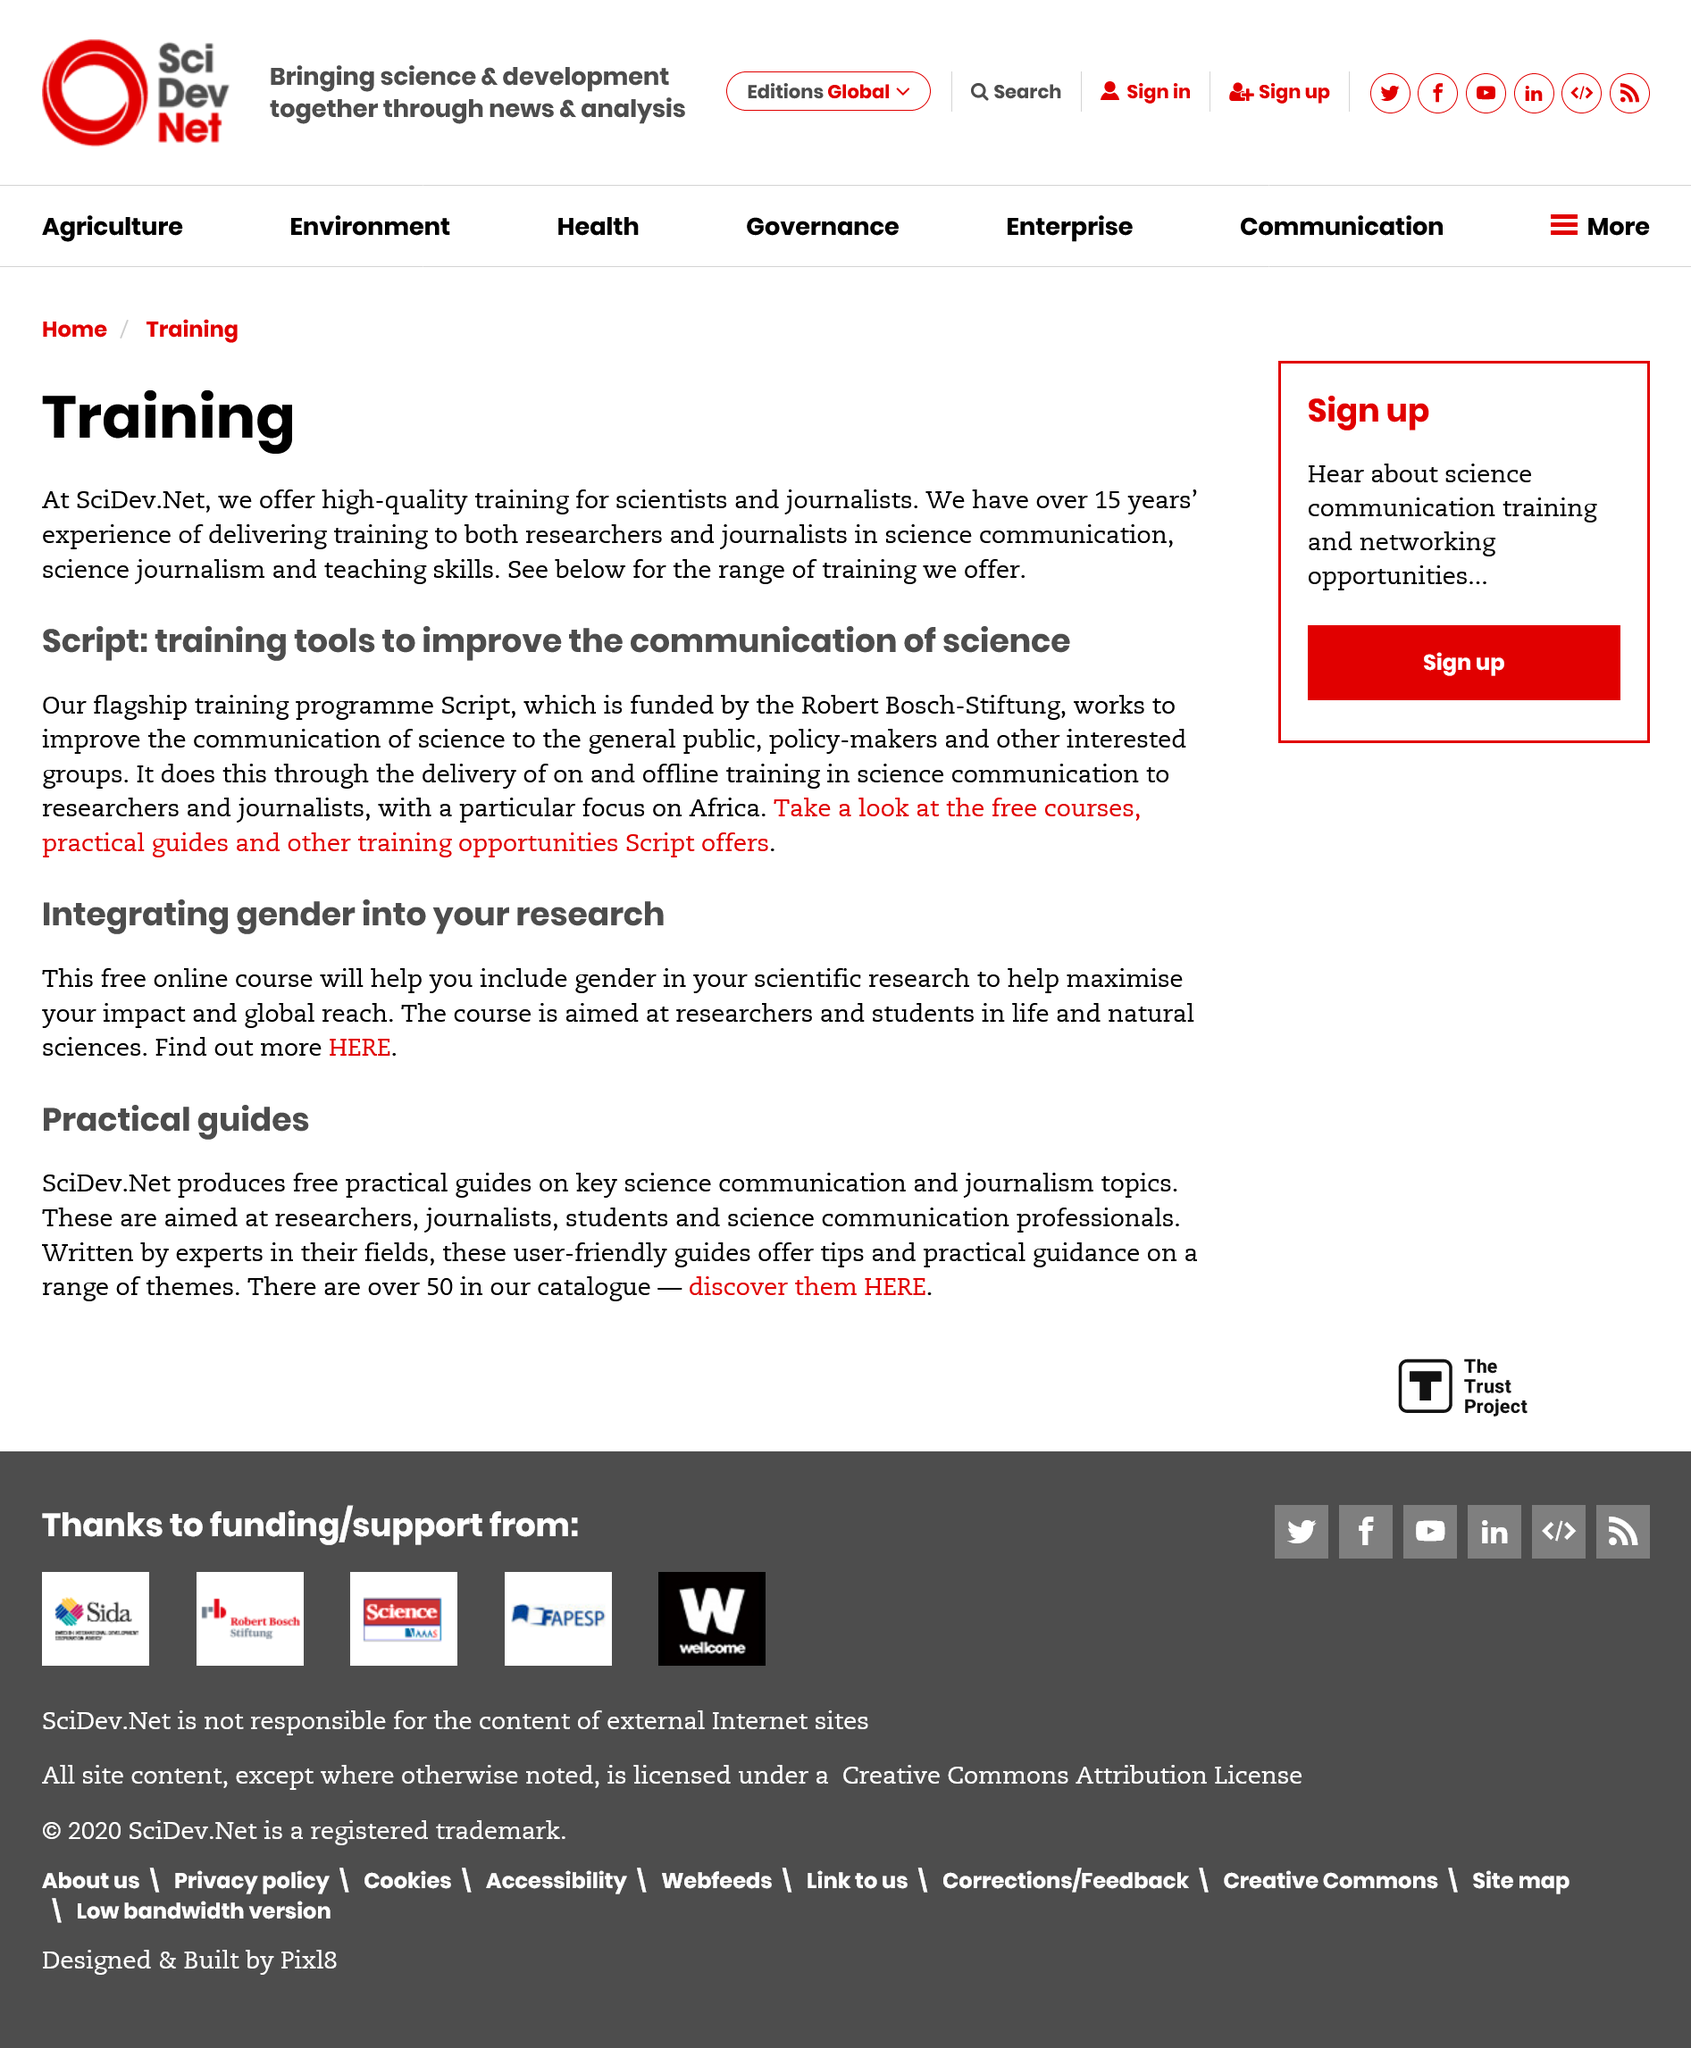Mention a couple of crucial points in this snapshot. SciDev.Net has been involved in training researchers and journalists for over 15 years and has extensive experience in delivering such training. The Robert Bosch-Siftung funds Script. SciDev.Net helps the general public understand science through its training program, Script, which equips researchers and journalists with the skills to communicate science effectively. 